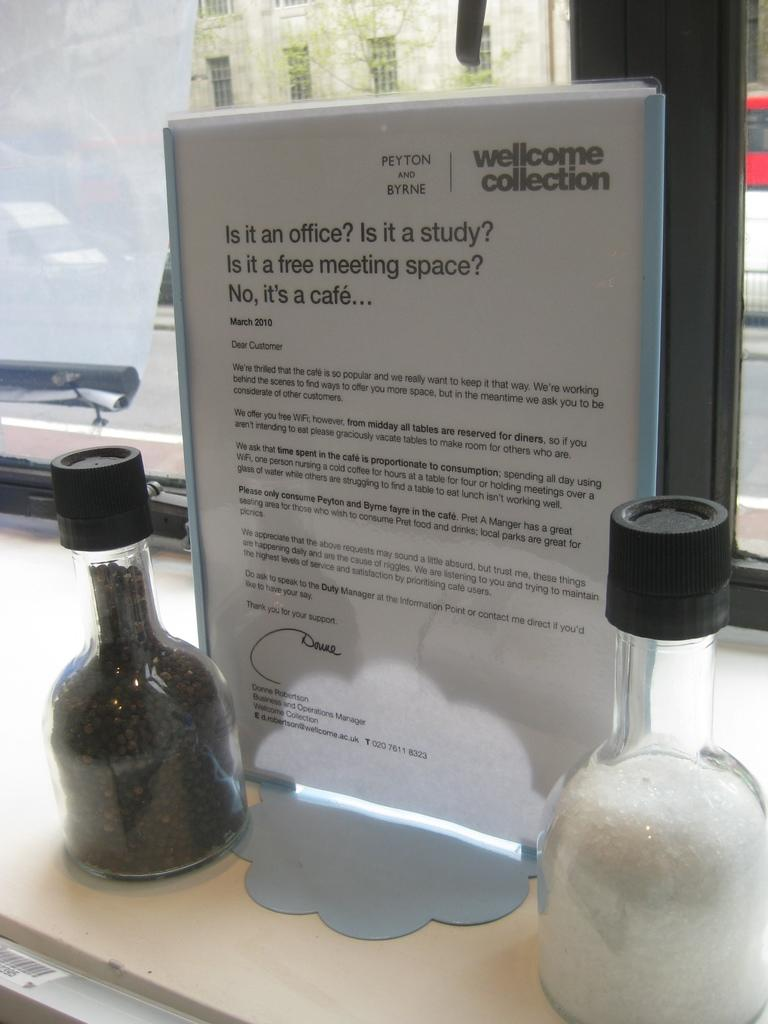What type of containers are present in the image? There are two glass bottles in the image. What other object can be seen in the image? There is a paper file in the image. What type of cord is attached to the paper file in the image? There is no cord attached to the paper file in the image. 